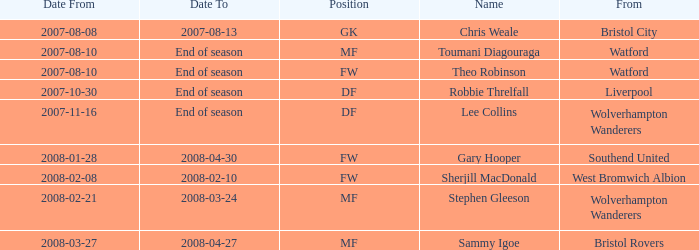What was the title for the row with date from of 2008-02-21? Stephen Gleeson. 